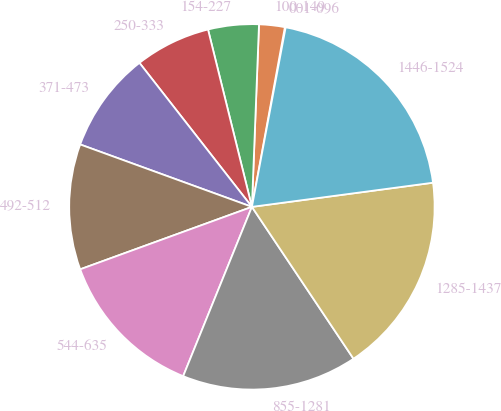<chart> <loc_0><loc_0><loc_500><loc_500><pie_chart><fcel>001-096<fcel>100-149<fcel>154-227<fcel>250-333<fcel>371-473<fcel>492-512<fcel>544-635<fcel>855-1281<fcel>1285-1437<fcel>1446-1524<nl><fcel>0.07%<fcel>2.27%<fcel>4.48%<fcel>6.69%<fcel>8.9%<fcel>11.1%<fcel>13.31%<fcel>15.52%<fcel>17.73%<fcel>19.93%<nl></chart> 